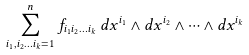<formula> <loc_0><loc_0><loc_500><loc_500>\sum _ { i _ { 1 } , i _ { 2 } \dots i _ { k } = 1 } ^ { n } f _ { i _ { 1 } i _ { 2 } \dots i _ { k } } \, d x ^ { i _ { 1 } } \wedge d x ^ { i _ { 2 } } \wedge \cdots \wedge d x ^ { i _ { k } }</formula> 